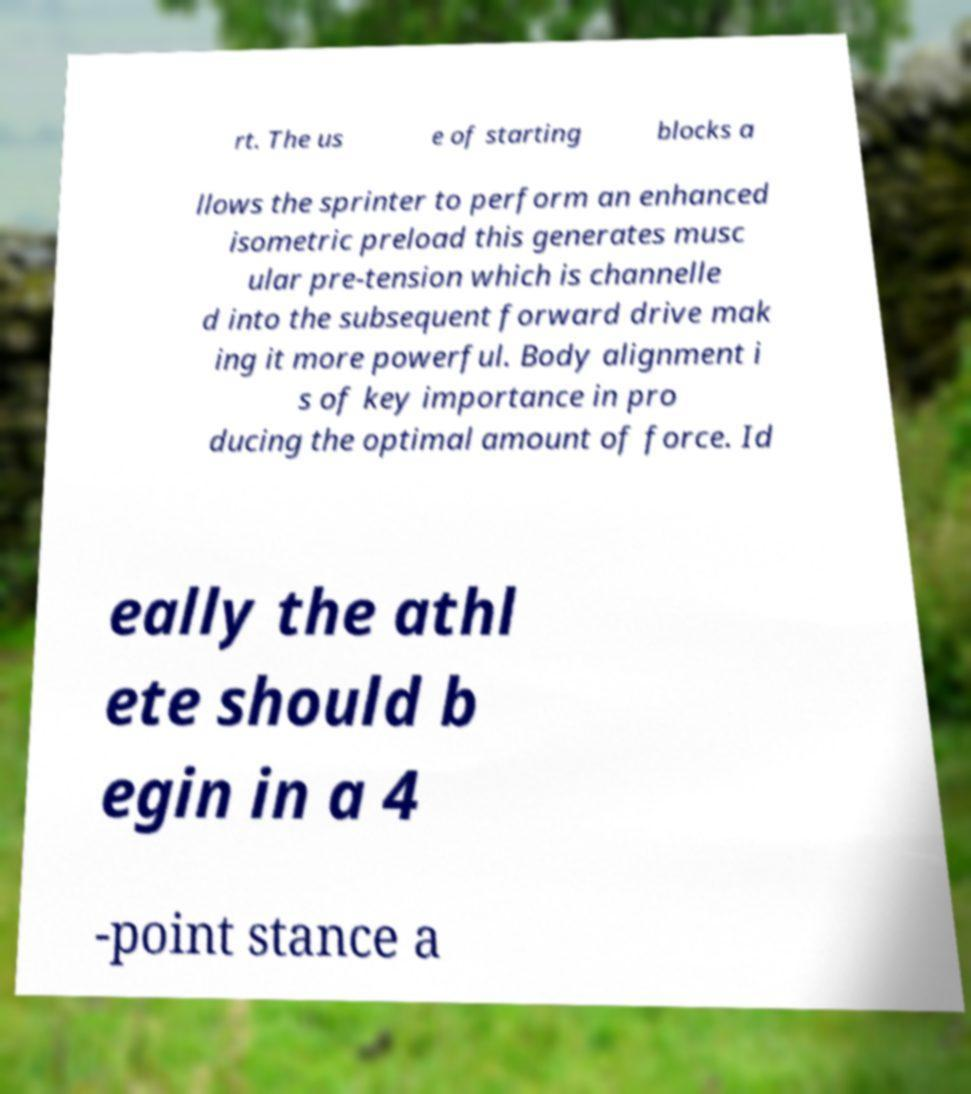What messages or text are displayed in this image? I need them in a readable, typed format. rt. The us e of starting blocks a llows the sprinter to perform an enhanced isometric preload this generates musc ular pre-tension which is channelle d into the subsequent forward drive mak ing it more powerful. Body alignment i s of key importance in pro ducing the optimal amount of force. Id eally the athl ete should b egin in a 4 -point stance a 